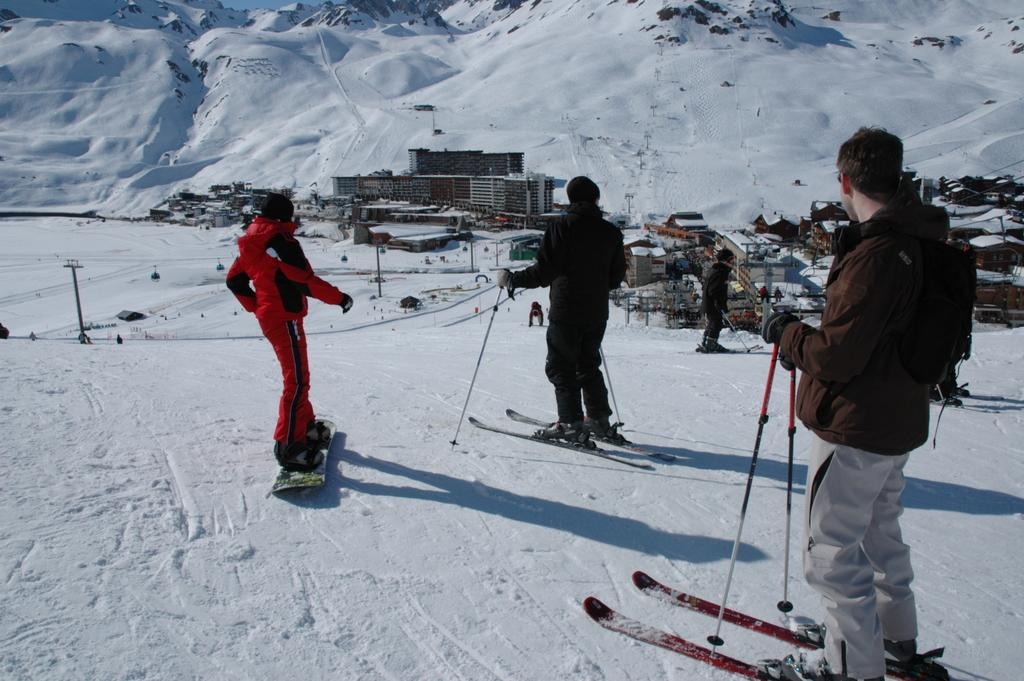How many people are in the image? There are people in the image, but the exact number is not specified. What are the people holding in their hands? The people are holding sticks in their hands. What are the people standing on? The people are standing on skis. What can be seen in the background of the image? In the background of the image, there are poles, buildings, and mountains. What is the ground made of in the image? The ground is covered in snow, as indicated by the fact that it is a snowy scene. What type of acoustics can be heard in the image? There is no information about sounds or acoustics in the image, so it cannot be determined. Can you see a glove on any of the people in the image? There is no mention of gloves in the image, so it cannot be determined if any are present. 